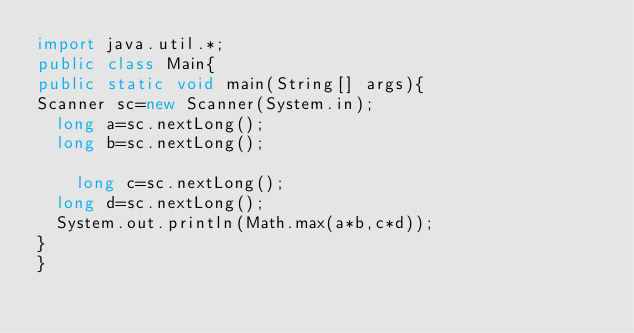<code> <loc_0><loc_0><loc_500><loc_500><_Java_>import java.util.*;
public class Main{
public static void main(String[] args){
Scanner sc=new Scanner(System.in);
  long a=sc.nextLong();
  long b=sc.nextLong();
  
    long c=sc.nextLong();
  long d=sc.nextLong();
  System.out.println(Math.max(a*b,c*d));
}
}</code> 